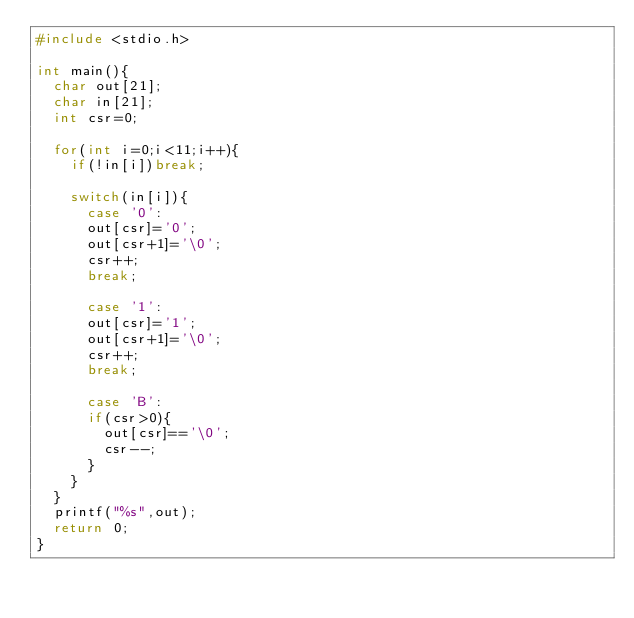<code> <loc_0><loc_0><loc_500><loc_500><_C++_>#include <stdio.h>

int main(){
	char out[21];
	char in[21];
	int csr=0;

	for(int i=0;i<11;i++){
		if(!in[i])break;

		switch(in[i]){
			case '0':
			out[csr]='0';
			out[csr+1]='\0';
			csr++;
			break;

			case '1':
			out[csr]='1';
			out[csr+1]='\0';
			csr++;
			break;

			case 'B':
			if(csr>0){
				out[csr]=='\0';
				csr--;
			}
		}
	}
	printf("%s",out);
	return 0;
}</code> 